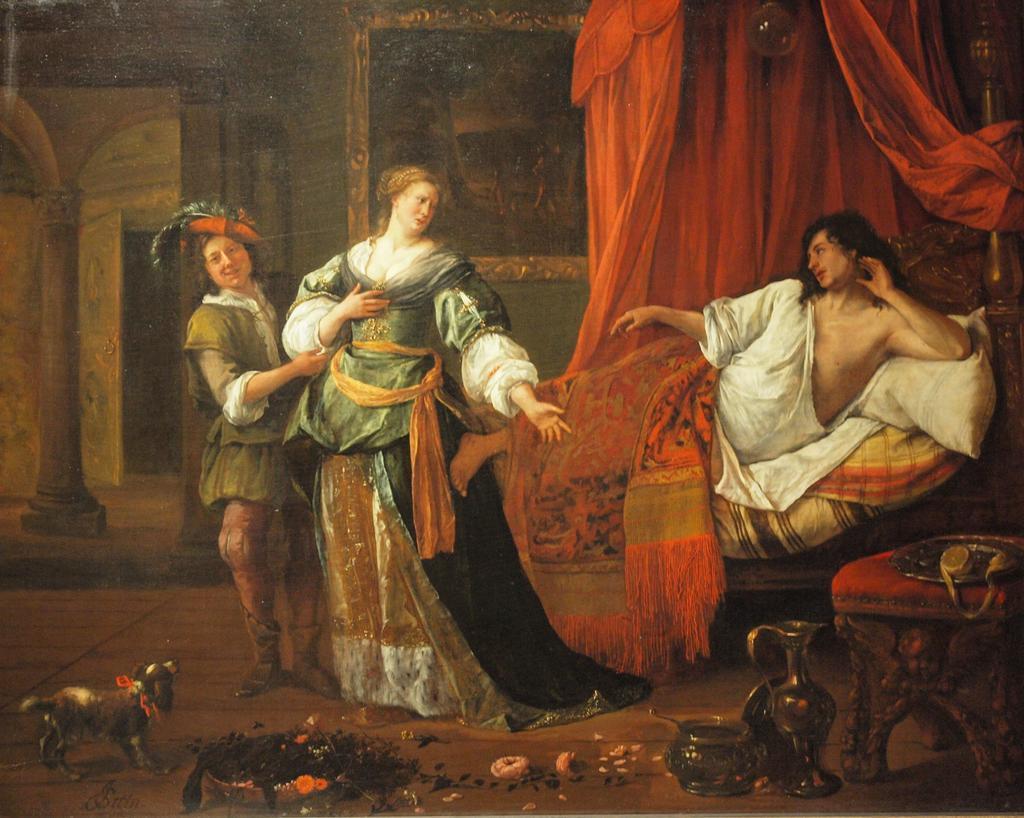Could you give a brief overview of what you see in this image? In this image I can see the painting of three people with the dresses. In-front of these people I can see the toy, jug, bowl and few objects on the stool. In the background I can see the cloth and the frame to the wall. 